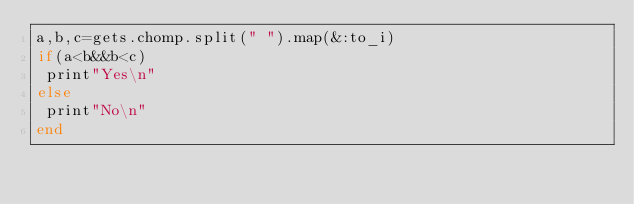Convert code to text. <code><loc_0><loc_0><loc_500><loc_500><_Ruby_>a,b,c=gets.chomp.split(" ").map(&:to_i)
if(a<b&&b<c)
 print"Yes\n"
else
 print"No\n"
end
</code> 